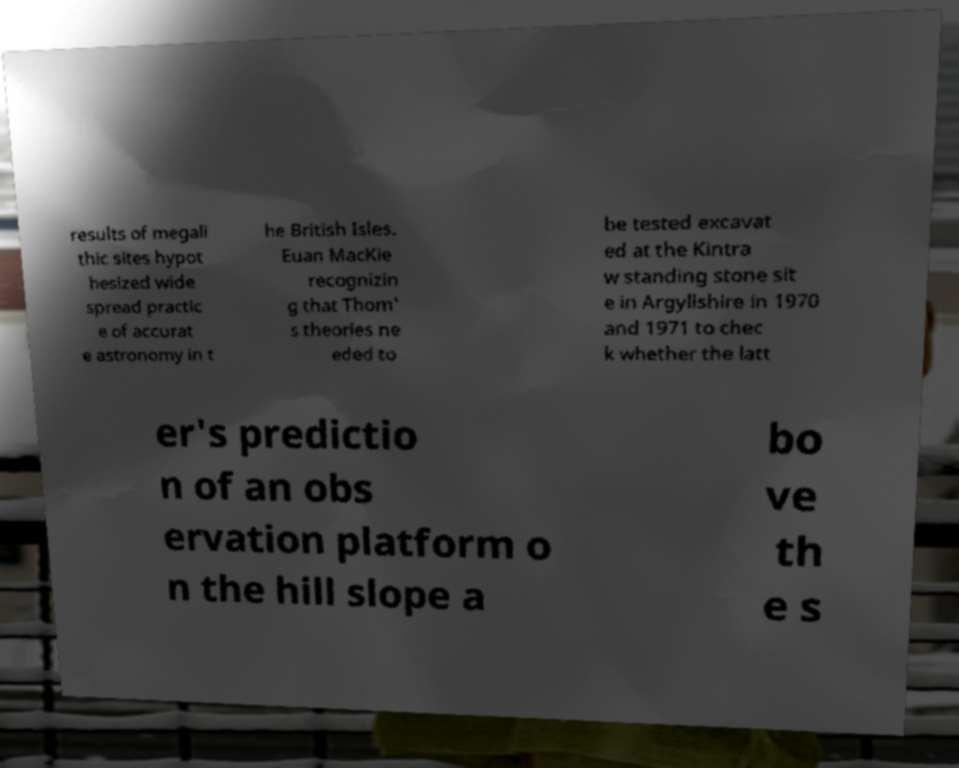What messages or text are displayed in this image? I need them in a readable, typed format. results of megali thic sites hypot hesized wide spread practic e of accurat e astronomy in t he British Isles. Euan MacKie recognizin g that Thom' s theories ne eded to be tested excavat ed at the Kintra w standing stone sit e in Argyllshire in 1970 and 1971 to chec k whether the latt er's predictio n of an obs ervation platform o n the hill slope a bo ve th e s 